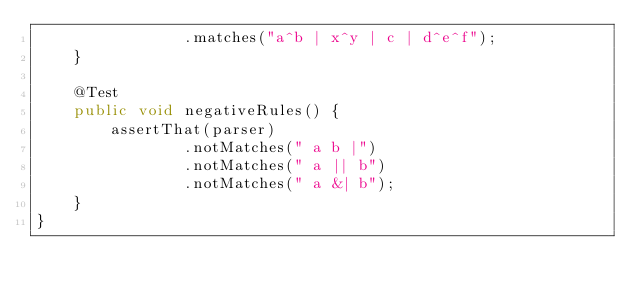Convert code to text. <code><loc_0><loc_0><loc_500><loc_500><_Java_>                .matches("a^b | x^y | c | d^e^f");
    }
    
    @Test
    public void negativeRules() {
        assertThat(parser)
                .notMatches(" a b |")
                .notMatches(" a || b")
                .notMatches(" a &| b");
    }
}
</code> 